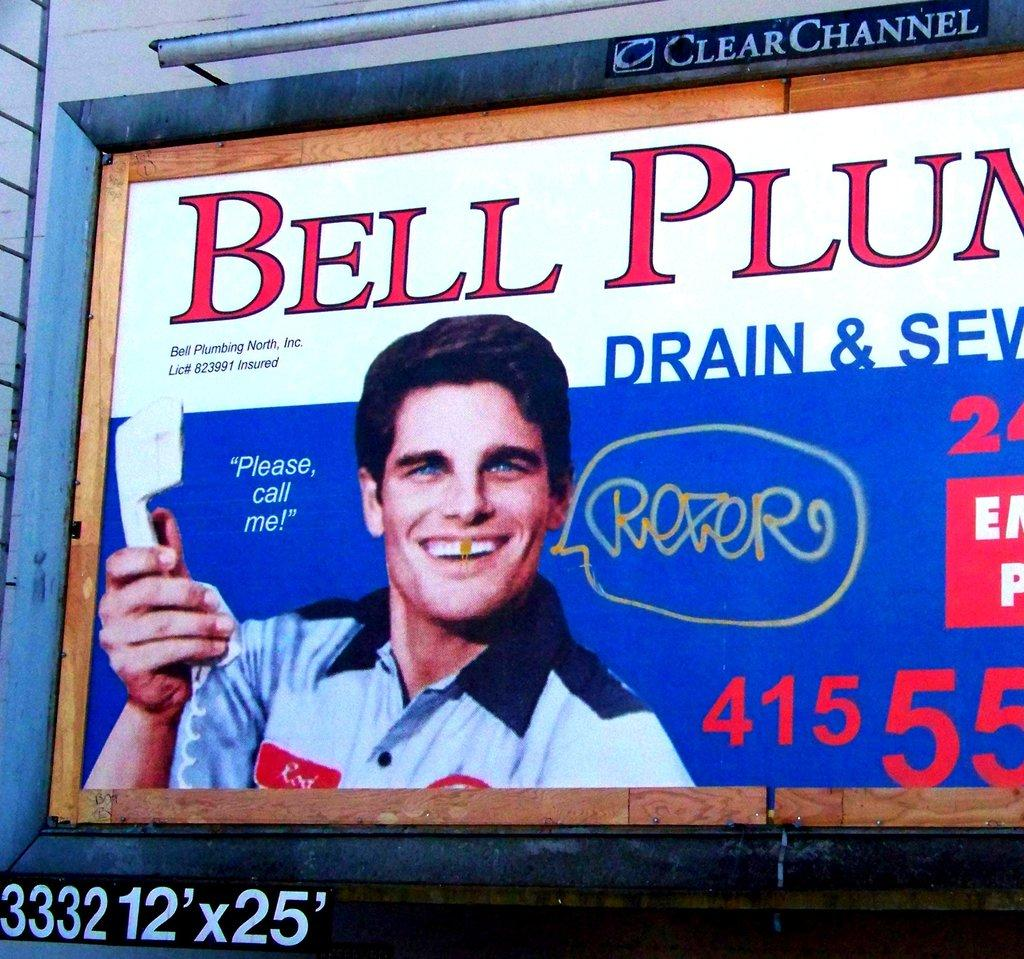<image>
Summarize the visual content of the image. A billboard for Bell Plumbing has been tagged. 